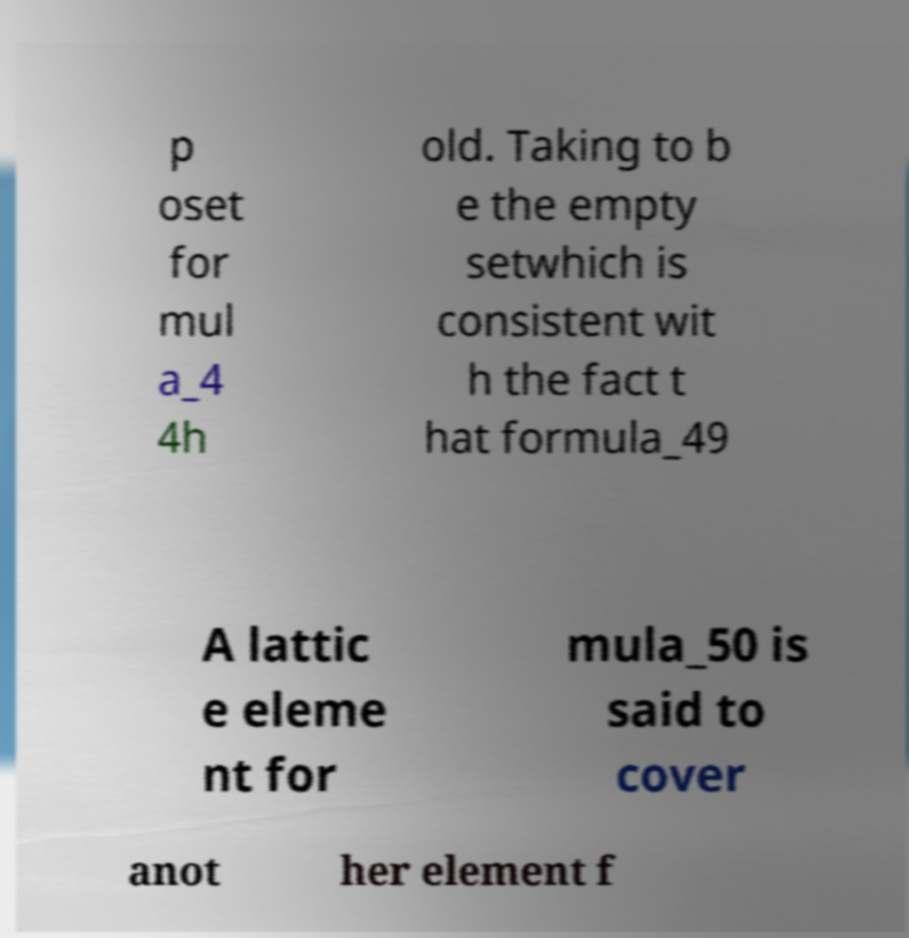Please identify and transcribe the text found in this image. p oset for mul a_4 4h old. Taking to b e the empty setwhich is consistent wit h the fact t hat formula_49 A lattic e eleme nt for mula_50 is said to cover anot her element f 